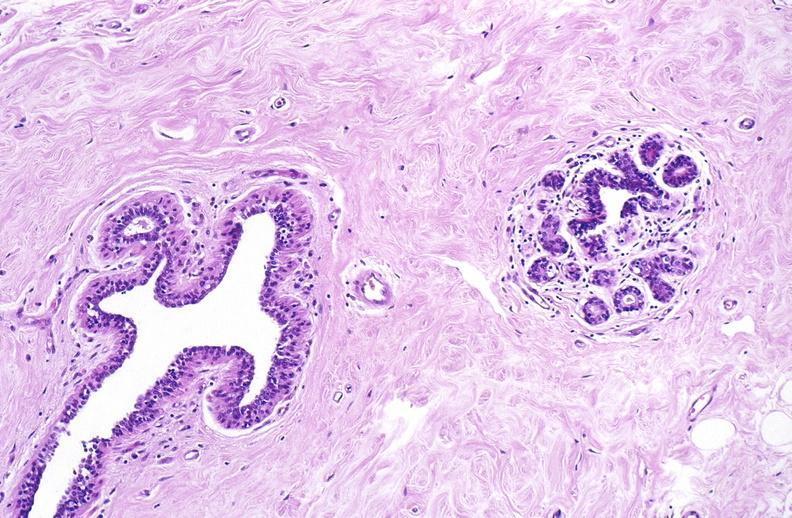where is this area in the body?
Answer the question using a single word or phrase. Breast 